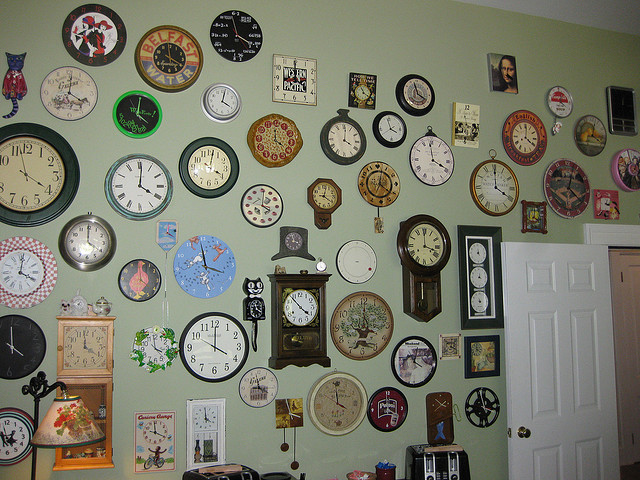How many clocks? There are approximately 28 clocks covering the wall, each with a unique design and theme. 